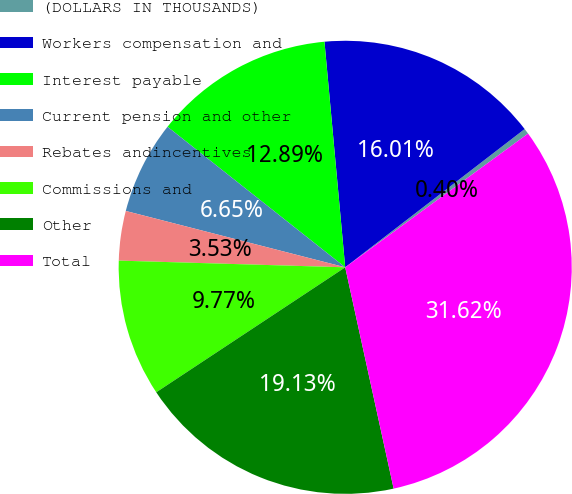Convert chart. <chart><loc_0><loc_0><loc_500><loc_500><pie_chart><fcel>(DOLLARS IN THOUSANDS)<fcel>Workers compensation and<fcel>Interest payable<fcel>Current pension and other<fcel>Rebates andincentives<fcel>Commissions and<fcel>Other<fcel>Total<nl><fcel>0.4%<fcel>16.01%<fcel>12.89%<fcel>6.65%<fcel>3.53%<fcel>9.77%<fcel>19.13%<fcel>31.62%<nl></chart> 